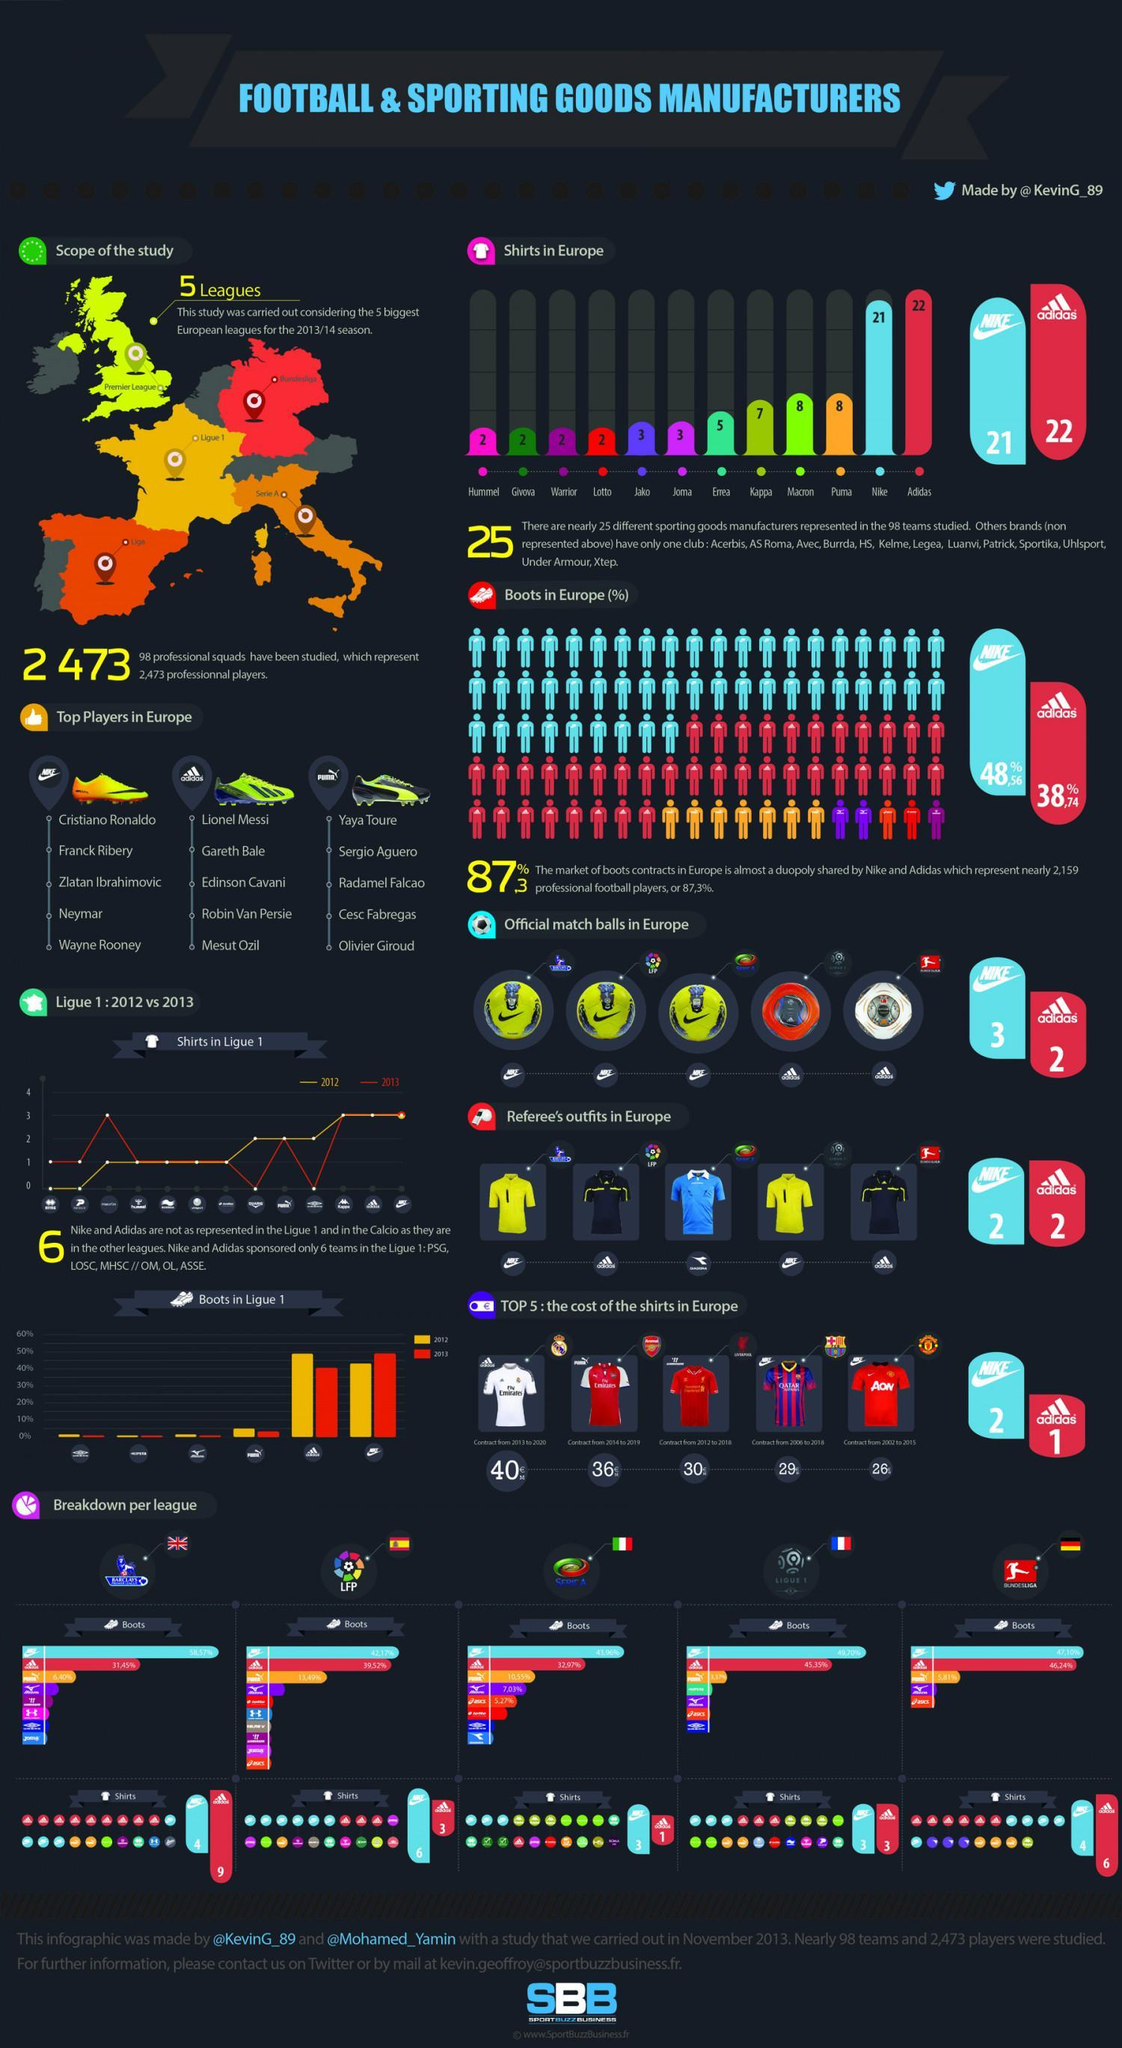What is the number of shirts made by Nike in Europe?
Answer the question with a short phrase. 21 What is the number of shirts made by Puma in Europe? 8 What is the percentage share by Nike in the market of boots contracts in Europe? 48,56% Which brand produces the most number of shirts in Europe? Adidas What is the percentage share by Adidas in the market of boots contracts in Europe? 38,74% 